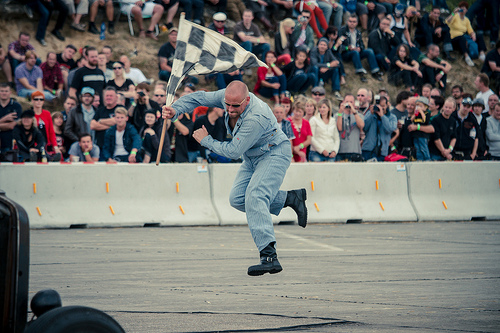<image>
Is there a man next to the flag? No. The man is not positioned next to the flag. They are located in different areas of the scene. Is there a feet above the ground? No. The feet is not positioned above the ground. The vertical arrangement shows a different relationship. 